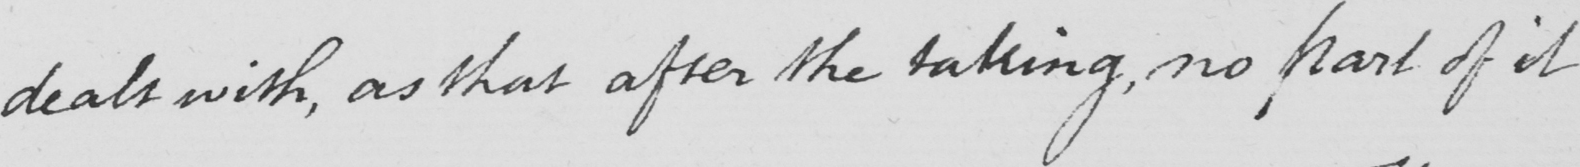What text is written in this handwritten line? dealt with , as that after the taking , no part of it 